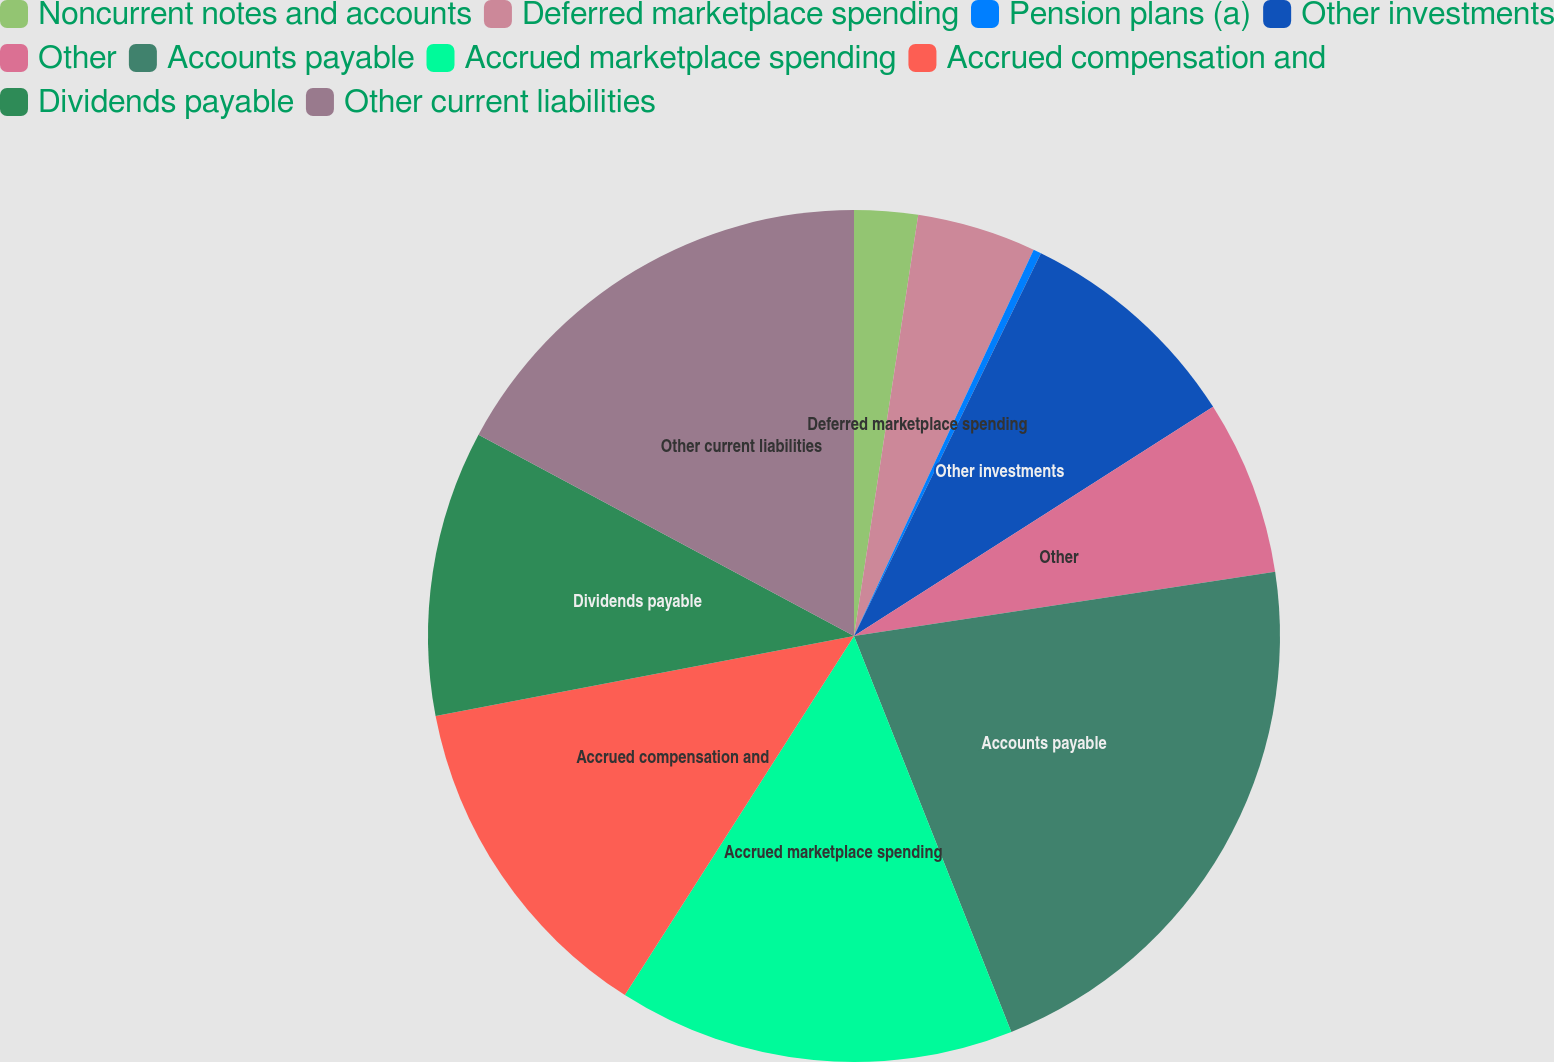Convert chart to OTSL. <chart><loc_0><loc_0><loc_500><loc_500><pie_chart><fcel>Noncurrent notes and accounts<fcel>Deferred marketplace spending<fcel>Pension plans (a)<fcel>Other investments<fcel>Other<fcel>Accounts payable<fcel>Accrued marketplace spending<fcel>Accrued compensation and<fcel>Dividends payable<fcel>Other current liabilities<nl><fcel>2.41%<fcel>4.52%<fcel>0.3%<fcel>8.73%<fcel>6.63%<fcel>21.39%<fcel>15.06%<fcel>12.95%<fcel>10.84%<fcel>17.17%<nl></chart> 